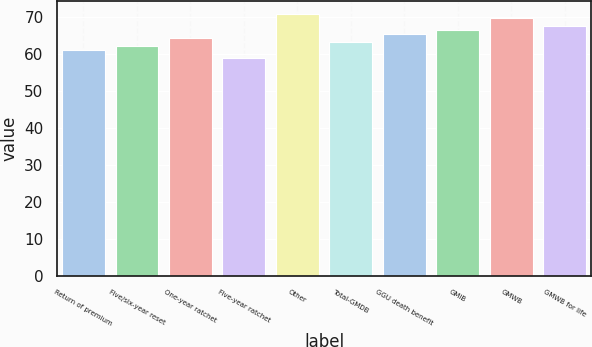<chart> <loc_0><loc_0><loc_500><loc_500><bar_chart><fcel>Return of premium<fcel>Five/six-year reset<fcel>One-year ratchet<fcel>Five-year ratchet<fcel>Other<fcel>Total-GMDB<fcel>GGU death benefit<fcel>GMIB<fcel>GMWB<fcel>GMWB for life<nl><fcel>61<fcel>62.1<fcel>64.3<fcel>59<fcel>70.9<fcel>63.2<fcel>65.4<fcel>66.5<fcel>69.8<fcel>67.6<nl></chart> 